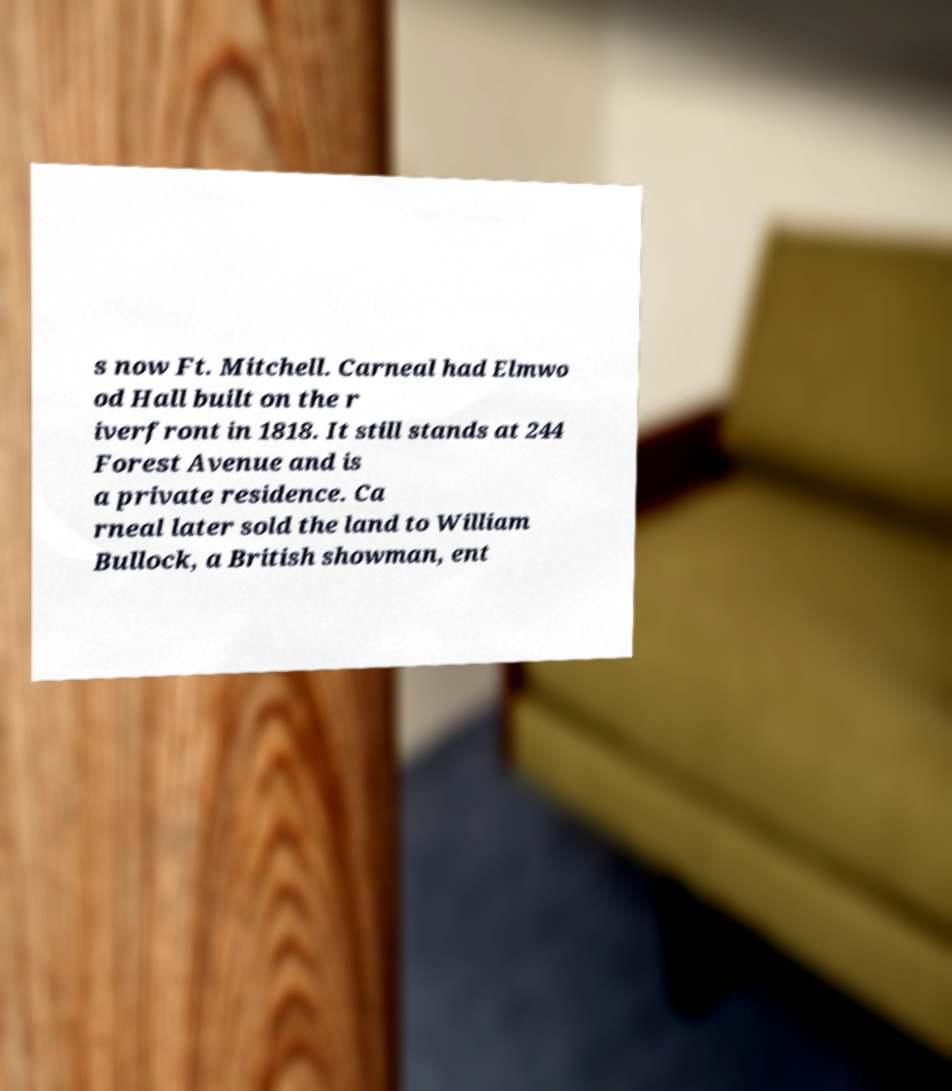Please identify and transcribe the text found in this image. s now Ft. Mitchell. Carneal had Elmwo od Hall built on the r iverfront in 1818. It still stands at 244 Forest Avenue and is a private residence. Ca rneal later sold the land to William Bullock, a British showman, ent 